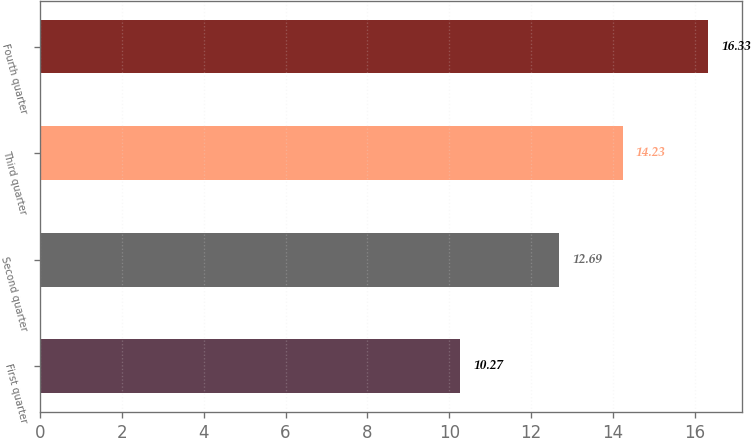Convert chart to OTSL. <chart><loc_0><loc_0><loc_500><loc_500><bar_chart><fcel>First quarter<fcel>Second quarter<fcel>Third quarter<fcel>Fourth quarter<nl><fcel>10.27<fcel>12.69<fcel>14.23<fcel>16.33<nl></chart> 